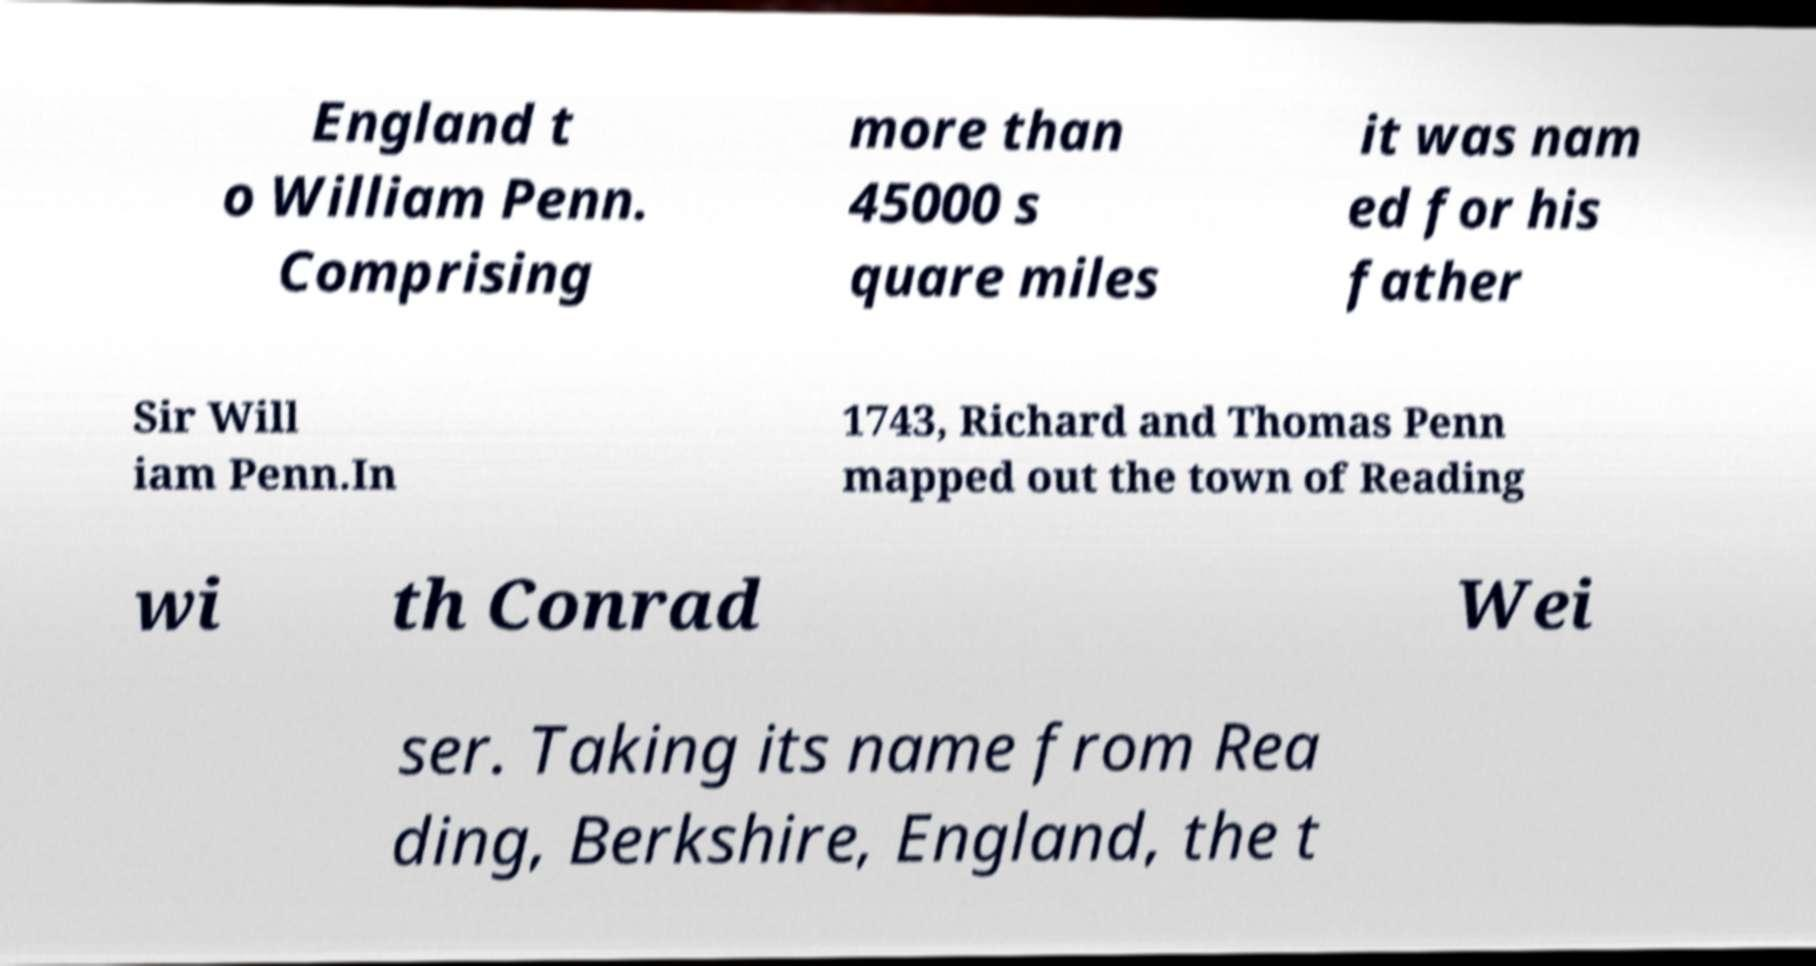Please read and relay the text visible in this image. What does it say? England t o William Penn. Comprising more than 45000 s quare miles it was nam ed for his father Sir Will iam Penn.In 1743, Richard and Thomas Penn mapped out the town of Reading wi th Conrad Wei ser. Taking its name from Rea ding, Berkshire, England, the t 